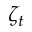<formula> <loc_0><loc_0><loc_500><loc_500>\zeta _ { t }</formula> 